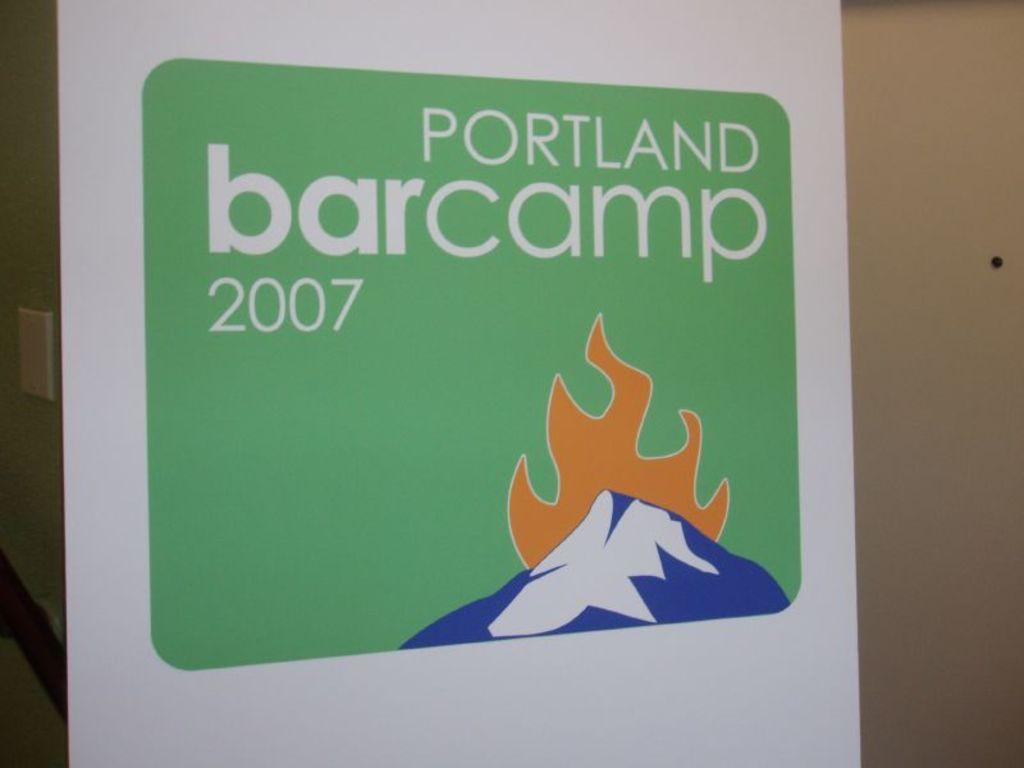<image>
Write a terse but informative summary of the picture. a sign that says portland camp on it with a mountain scene. 